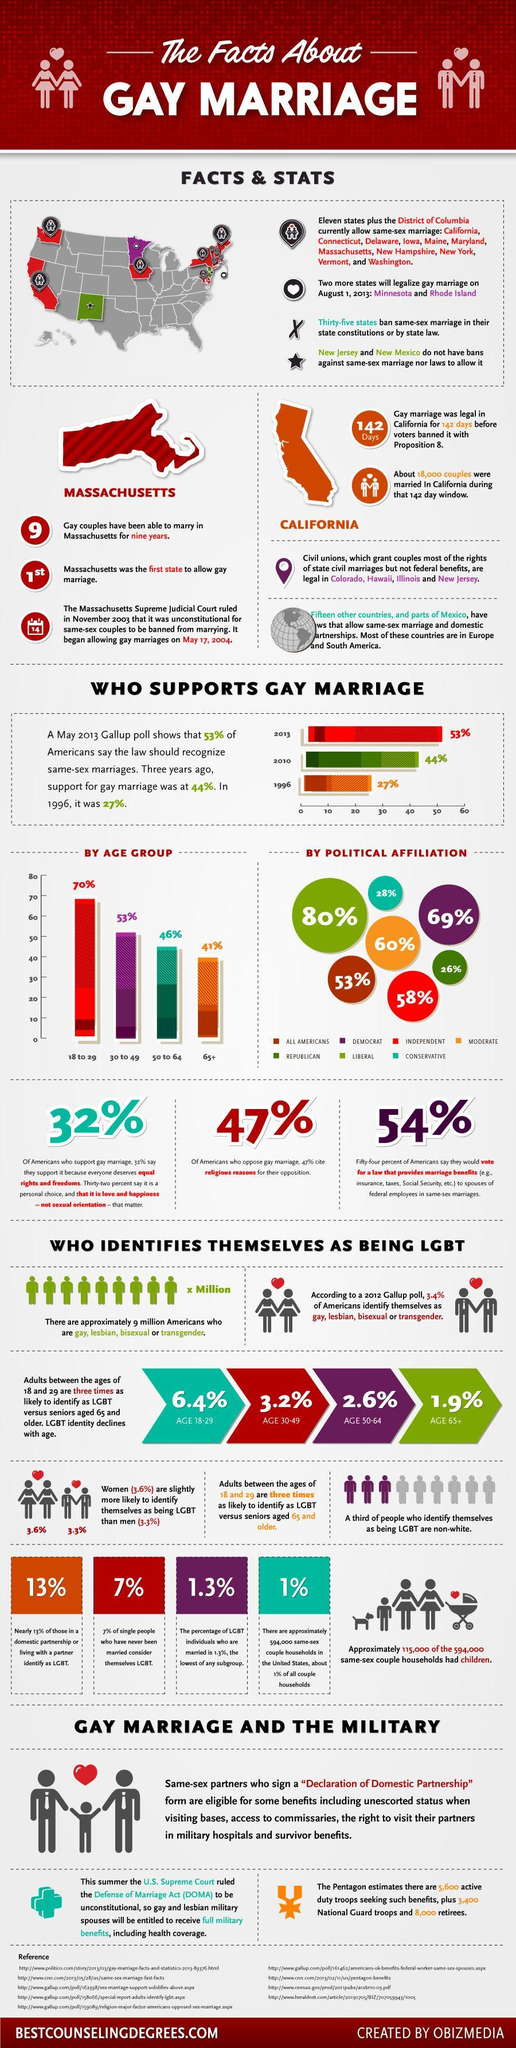By what percentage did support for gay marriage increase from 1996 to 2013?
Answer the question with a short phrase. 26% What percent of senior citizens support gay marriage? 41% By what percent does the support for gay marriage differ among Democrats and Republicans? 43% What percent of Conservatives support gay marriage? 28% Which political affiliation supports gay marriage the most? LIBERAL How many references are cited? 9 